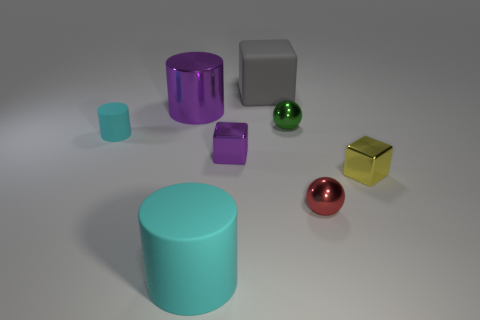There is a tiny cube that is the same color as the large metal thing; what is it made of?
Provide a short and direct response. Metal. Is there a big matte thing of the same color as the tiny cylinder?
Provide a succinct answer. Yes. There is a cyan rubber object right of the tiny thing that is left of the shiny cylinder; what shape is it?
Your answer should be very brief. Cylinder. How big is the rubber cylinder that is behind the big cyan rubber object?
Give a very brief answer. Small. Are the gray block and the purple cube made of the same material?
Give a very brief answer. No. There is a big thing that is made of the same material as the yellow block; what shape is it?
Keep it short and to the point. Cylinder. Are there any other things of the same color as the matte block?
Make the answer very short. No. The large cylinder in front of the green thing is what color?
Make the answer very short. Cyan. There is a tiny block that is to the left of the tiny green object; is its color the same as the big metallic cylinder?
Offer a very short reply. Yes. What is the material of the small cyan object that is the same shape as the big cyan object?
Your response must be concise. Rubber. 